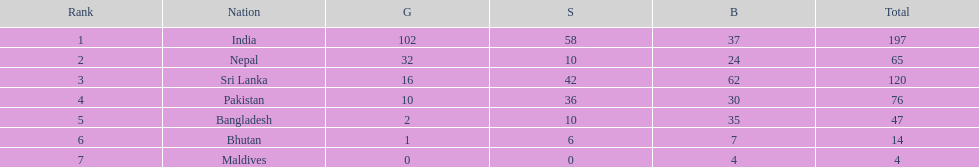How many more gold medals has nepal won than pakistan? 22. 